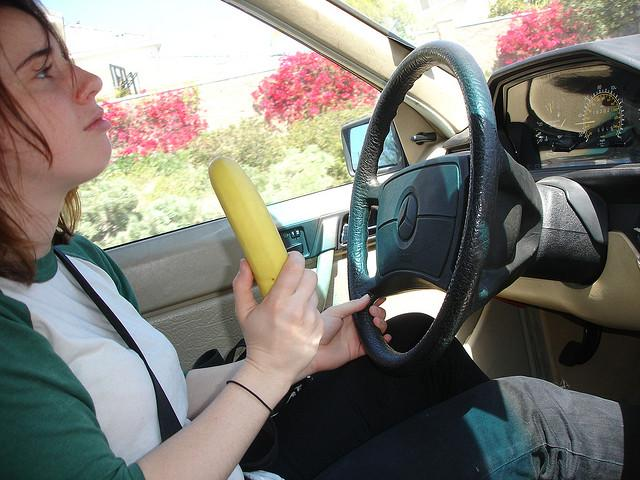Where do bananas originally come from? Please explain your reasoning. asia. They are from the southeastern part of the continent, which is tropical. 